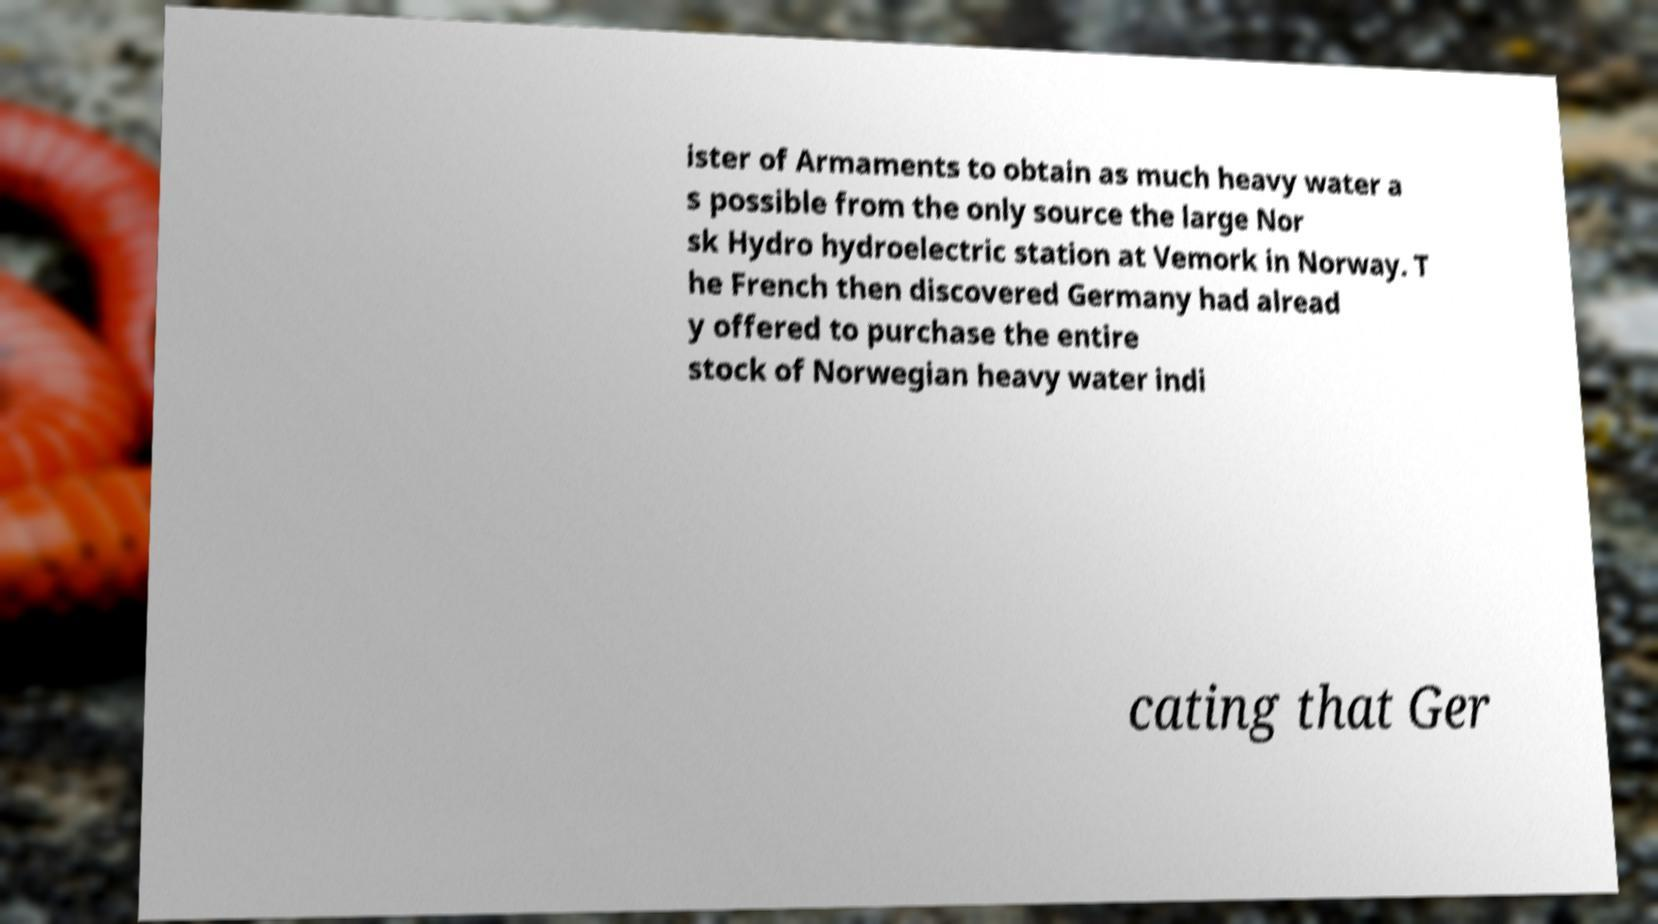Could you extract and type out the text from this image? ister of Armaments to obtain as much heavy water a s possible from the only source the large Nor sk Hydro hydroelectric station at Vemork in Norway. T he French then discovered Germany had alread y offered to purchase the entire stock of Norwegian heavy water indi cating that Ger 